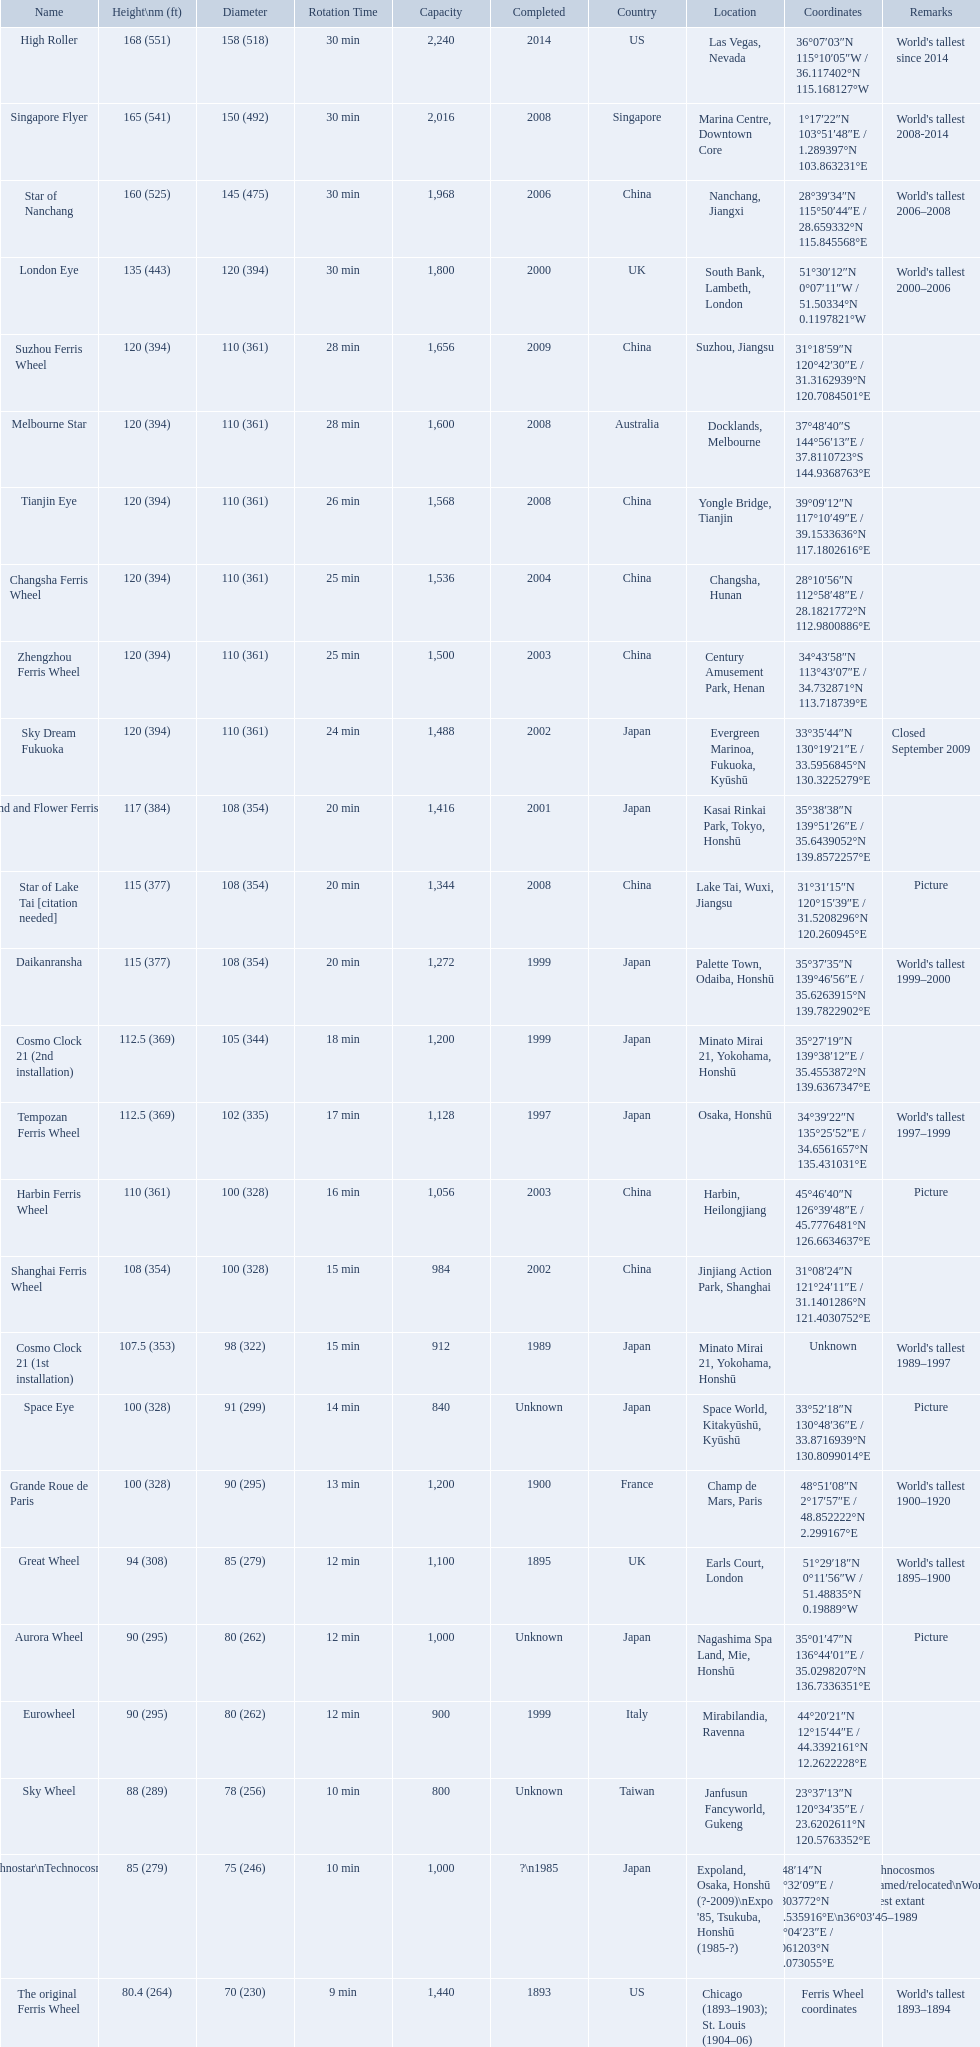When was the high roller ferris wheel completed? 2014. Which ferris wheel was completed in 2006? Star of Nanchang. Which one was completed in 2008? Singapore Flyer. What are all of the ferris wheel names? High Roller, Singapore Flyer, Star of Nanchang, London Eye, Suzhou Ferris Wheel, Melbourne Star, Tianjin Eye, Changsha Ferris Wheel, Zhengzhou Ferris Wheel, Sky Dream Fukuoka, Diamond and Flower Ferris Wheel, Star of Lake Tai [citation needed], Daikanransha, Cosmo Clock 21 (2nd installation), Tempozan Ferris Wheel, Harbin Ferris Wheel, Shanghai Ferris Wheel, Cosmo Clock 21 (1st installation), Space Eye, Grande Roue de Paris, Great Wheel, Aurora Wheel, Eurowheel, Sky Wheel, Technostar\nTechnocosmos, The original Ferris Wheel. What was the height of each one? 168 (551), 165 (541), 160 (525), 135 (443), 120 (394), 120 (394), 120 (394), 120 (394), 120 (394), 120 (394), 117 (384), 115 (377), 115 (377), 112.5 (369), 112.5 (369), 110 (361), 108 (354), 107.5 (353), 100 (328), 100 (328), 94 (308), 90 (295), 90 (295), 88 (289), 85 (279), 80.4 (264). And when were they completed? 2014, 2008, 2006, 2000, 2009, 2008, 2008, 2004, 2003, 2002, 2001, 2008, 1999, 1999, 1997, 2003, 2002, 1989, Unknown, 1900, 1895, Unknown, 1999, Unknown, ?\n1985, 1893. Which were completed in 2008? Singapore Flyer, Melbourne Star, Tianjin Eye, Star of Lake Tai [citation needed]. And of those ferris wheels, which had a height of 165 meters? Singapore Flyer. What are all of the ferris wheels? High Roller, Singapore Flyer, Star of Nanchang, London Eye, Suzhou Ferris Wheel, Melbourne Star, Tianjin Eye, Changsha Ferris Wheel, Zhengzhou Ferris Wheel, Sky Dream Fukuoka, Diamond and Flower Ferris Wheel, Star of Lake Tai [citation needed], Daikanransha, Cosmo Clock 21 (2nd installation), Tempozan Ferris Wheel, Harbin Ferris Wheel, Shanghai Ferris Wheel, Cosmo Clock 21 (1st installation), Space Eye, Grande Roue de Paris, Great Wheel, Aurora Wheel, Eurowheel, Sky Wheel, Technostar\nTechnocosmos, The original Ferris Wheel. Help me parse the entirety of this table. {'header': ['Name', 'Height\\nm (ft)', 'Diameter', 'Rotation Time', 'Capacity', 'Completed', 'Country', 'Location', 'Coordinates', 'Remarks'], 'rows': [['High Roller', '168 (551)', '158 (518)', '30 min', '2,240', '2014', 'US', 'Las Vegas, Nevada', '36°07′03″N 115°10′05″W\ufeff / \ufeff36.117402°N 115.168127°W', "World's tallest since 2014"], ['Singapore Flyer', '165 (541)', '150 (492)', '30 min', '2,016', '2008', 'Singapore', 'Marina Centre, Downtown Core', '1°17′22″N 103°51′48″E\ufeff / \ufeff1.289397°N 103.863231°E', "World's tallest 2008-2014"], ['Star of Nanchang', '160 (525)', '145 (475)', '30 min', '1,968', '2006', 'China', 'Nanchang, Jiangxi', '28°39′34″N 115°50′44″E\ufeff / \ufeff28.659332°N 115.845568°E', "World's tallest 2006–2008"], ['London Eye', '135 (443)', '120 (394)', '30 min', '1,800', '2000', 'UK', 'South Bank, Lambeth, London', '51°30′12″N 0°07′11″W\ufeff / \ufeff51.50334°N 0.1197821°W', "World's tallest 2000–2006"], ['Suzhou Ferris Wheel', '120 (394)', '110 (361)', '28 min', '1,656', '2009', 'China', 'Suzhou, Jiangsu', '31°18′59″N 120°42′30″E\ufeff / \ufeff31.3162939°N 120.7084501°E', ''], ['Melbourne Star', '120 (394)', '110 (361)', '28 min', '1,600', '2008', 'Australia', 'Docklands, Melbourne', '37°48′40″S 144°56′13″E\ufeff / \ufeff37.8110723°S 144.9368763°E', ''], ['Tianjin Eye', '120 (394)', '110 (361)', '26 min', '1,568', '2008', 'China', 'Yongle Bridge, Tianjin', '39°09′12″N 117°10′49″E\ufeff / \ufeff39.1533636°N 117.1802616°E', ''], ['Changsha Ferris Wheel', '120 (394)', '110 (361)', '25 min', '1,536', '2004', 'China', 'Changsha, Hunan', '28°10′56″N 112°58′48″E\ufeff / \ufeff28.1821772°N 112.9800886°E', ''], ['Zhengzhou Ferris Wheel', '120 (394)', '110 (361)', '25 min', '1,500', '2003', 'China', 'Century Amusement Park, Henan', '34°43′58″N 113°43′07″E\ufeff / \ufeff34.732871°N 113.718739°E', ''], ['Sky Dream Fukuoka', '120 (394)', '110 (361)', '24 min', '1,488', '2002', 'Japan', 'Evergreen Marinoa, Fukuoka, Kyūshū', '33°35′44″N 130°19′21″E\ufeff / \ufeff33.5956845°N 130.3225279°E', 'Closed September 2009'], ['Diamond\xa0and\xa0Flower\xa0Ferris\xa0Wheel', '117 (384)', '108 (354)', '20 min', '1,416', '2001', 'Japan', 'Kasai Rinkai Park, Tokyo, Honshū', '35°38′38″N 139°51′26″E\ufeff / \ufeff35.6439052°N 139.8572257°E', ''], ['Star of Lake Tai\xa0[citation needed]', '115 (377)', '108 (354)', '20 min', '1,344', '2008', 'China', 'Lake Tai, Wuxi, Jiangsu', '31°31′15″N 120°15′39″E\ufeff / \ufeff31.5208296°N 120.260945°E', 'Picture'], ['Daikanransha', '115 (377)', '108 (354)', '20 min', '1,272', '1999', 'Japan', 'Palette Town, Odaiba, Honshū', '35°37′35″N 139°46′56″E\ufeff / \ufeff35.6263915°N 139.7822902°E', "World's tallest 1999–2000"], ['Cosmo Clock 21 (2nd installation)', '112.5 (369)', '105 (344)', '18 min', '1,200', '1999', 'Japan', 'Minato Mirai 21, Yokohama, Honshū', '35°27′19″N 139°38′12″E\ufeff / \ufeff35.4553872°N 139.6367347°E', ''], ['Tempozan Ferris Wheel', '112.5 (369)', '102 (335)', '17 min', '1,128', '1997', 'Japan', 'Osaka, Honshū', '34°39′22″N 135°25′52″E\ufeff / \ufeff34.6561657°N 135.431031°E', "World's tallest 1997–1999"], ['Harbin Ferris Wheel', '110 (361)', '100 (328)', '16 min', '1,056', '2003', 'China', 'Harbin, Heilongjiang', '45°46′40″N 126°39′48″E\ufeff / \ufeff45.7776481°N 126.6634637°E', 'Picture'], ['Shanghai Ferris Wheel', '108 (354)', '100 (328)', '15 min', '984', '2002', 'China', 'Jinjiang Action Park, Shanghai', '31°08′24″N 121°24′11″E\ufeff / \ufeff31.1401286°N 121.4030752°E', ''], ['Cosmo Clock 21 (1st installation)', '107.5 (353)', '98 (322)', '15 min', '912', '1989', 'Japan', 'Minato Mirai 21, Yokohama, Honshū', 'Unknown', "World's tallest 1989–1997"], ['Space Eye', '100 (328)', '91 (299)', '14 min', '840', 'Unknown', 'Japan', 'Space World, Kitakyūshū, Kyūshū', '33°52′18″N 130°48′36″E\ufeff / \ufeff33.8716939°N 130.8099014°E', 'Picture'], ['Grande Roue de Paris', '100 (328)', '90 (295)', '13 min', '1,200', '1900', 'France', 'Champ de Mars, Paris', '48°51′08″N 2°17′57″E\ufeff / \ufeff48.852222°N 2.299167°E', "World's tallest 1900–1920"], ['Great Wheel', '94 (308)', '85 (279)', '12 min', '1,100', '1895', 'UK', 'Earls Court, London', '51°29′18″N 0°11′56″W\ufeff / \ufeff51.48835°N 0.19889°W', "World's tallest 1895–1900"], ['Aurora Wheel', '90 (295)', '80 (262)', '12 min', '1,000', 'Unknown', 'Japan', 'Nagashima Spa Land, Mie, Honshū', '35°01′47″N 136°44′01″E\ufeff / \ufeff35.0298207°N 136.7336351°E', 'Picture'], ['Eurowheel', '90 (295)', '80 (262)', '12 min', '900', '1999', 'Italy', 'Mirabilandia, Ravenna', '44°20′21″N 12°15′44″E\ufeff / \ufeff44.3392161°N 12.2622228°E', ''], ['Sky Wheel', '88 (289)', '78 (256)', '10 min', '800', 'Unknown', 'Taiwan', 'Janfusun Fancyworld, Gukeng', '23°37′13″N 120°34′35″E\ufeff / \ufeff23.6202611°N 120.5763352°E', ''], ['Technostar\\nTechnocosmos', '85 (279)', '75 (246)', '10 min', '1,000', '?\\n1985', 'Japan', "Expoland, Osaka, Honshū (?-2009)\\nExpo '85, Tsukuba, Honshū (1985-?)", '34°48′14″N 135°32′09″E\ufeff / \ufeff34.803772°N 135.535916°E\\n36°03′40″N 140°04′23″E\ufeff / \ufeff36.061203°N 140.073055°E', "Technocosmos renamed/relocated\\nWorld's tallest extant 1985–1989"], ['The original Ferris Wheel', '80.4 (264)', '70 (230)', '9 min', '1,440', '1893', 'US', 'Chicago (1893–1903); St. Louis (1904–06)', 'Ferris Wheel coordinates', "World's tallest 1893–1894"]]} And when were they completed? 2014, 2008, 2006, 2000, 2009, 2008, 2008, 2004, 2003, 2002, 2001, 2008, 1999, 1999, 1997, 2003, 2002, 1989, Unknown, 1900, 1895, Unknown, 1999, Unknown, ?\n1985, 1893. And among star of lake tai, star of nanchang, and melbourne star, which ferris wheel is oldest? Star of Nanchang. 